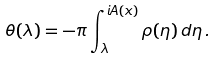Convert formula to latex. <formula><loc_0><loc_0><loc_500><loc_500>\theta ( \lambda ) = - \pi \int _ { \lambda } ^ { i A ( x ) } \rho ( \eta ) \, d \eta \, .</formula> 